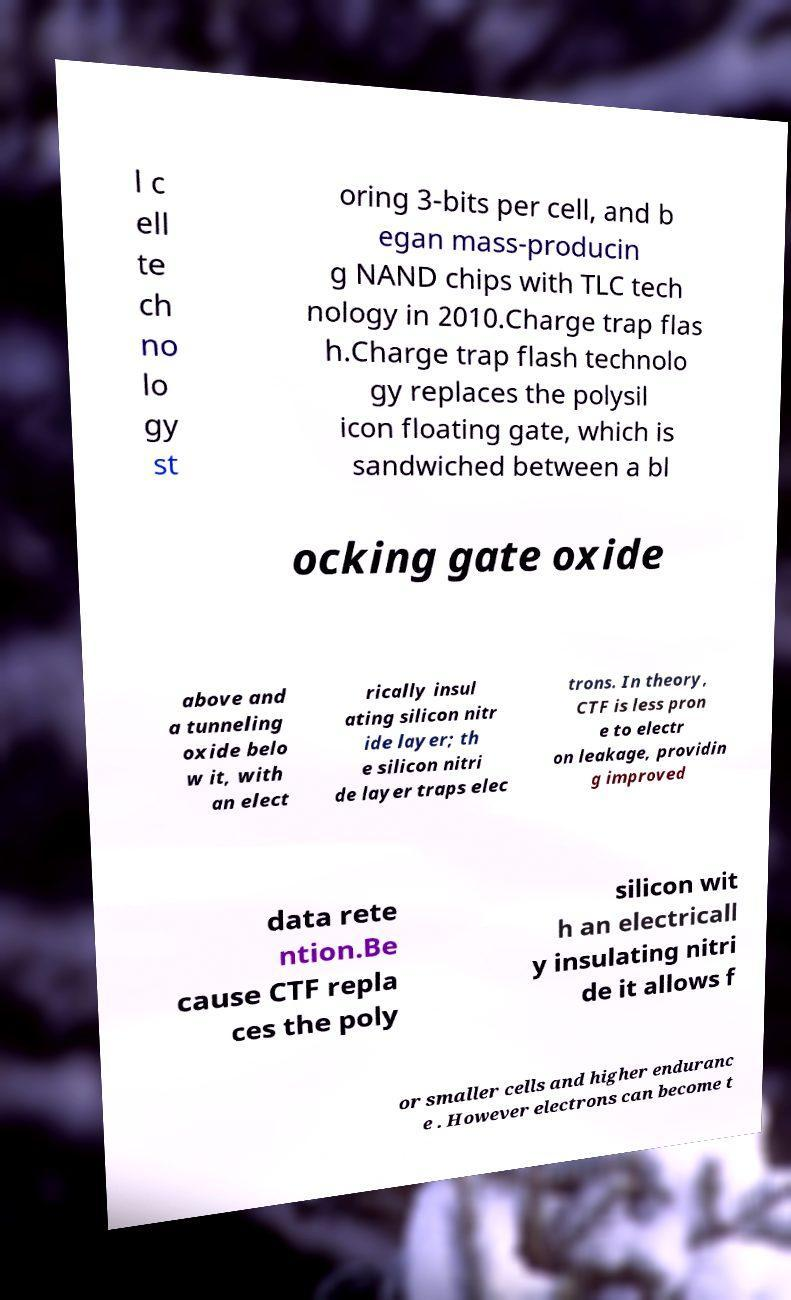Can you accurately transcribe the text from the provided image for me? l c ell te ch no lo gy st oring 3-bits per cell, and b egan mass-producin g NAND chips with TLC tech nology in 2010.Charge trap flas h.Charge trap flash technolo gy replaces the polysil icon floating gate, which is sandwiched between a bl ocking gate oxide above and a tunneling oxide belo w it, with an elect rically insul ating silicon nitr ide layer; th e silicon nitri de layer traps elec trons. In theory, CTF is less pron e to electr on leakage, providin g improved data rete ntion.Be cause CTF repla ces the poly silicon wit h an electricall y insulating nitri de it allows f or smaller cells and higher enduranc e . However electrons can become t 